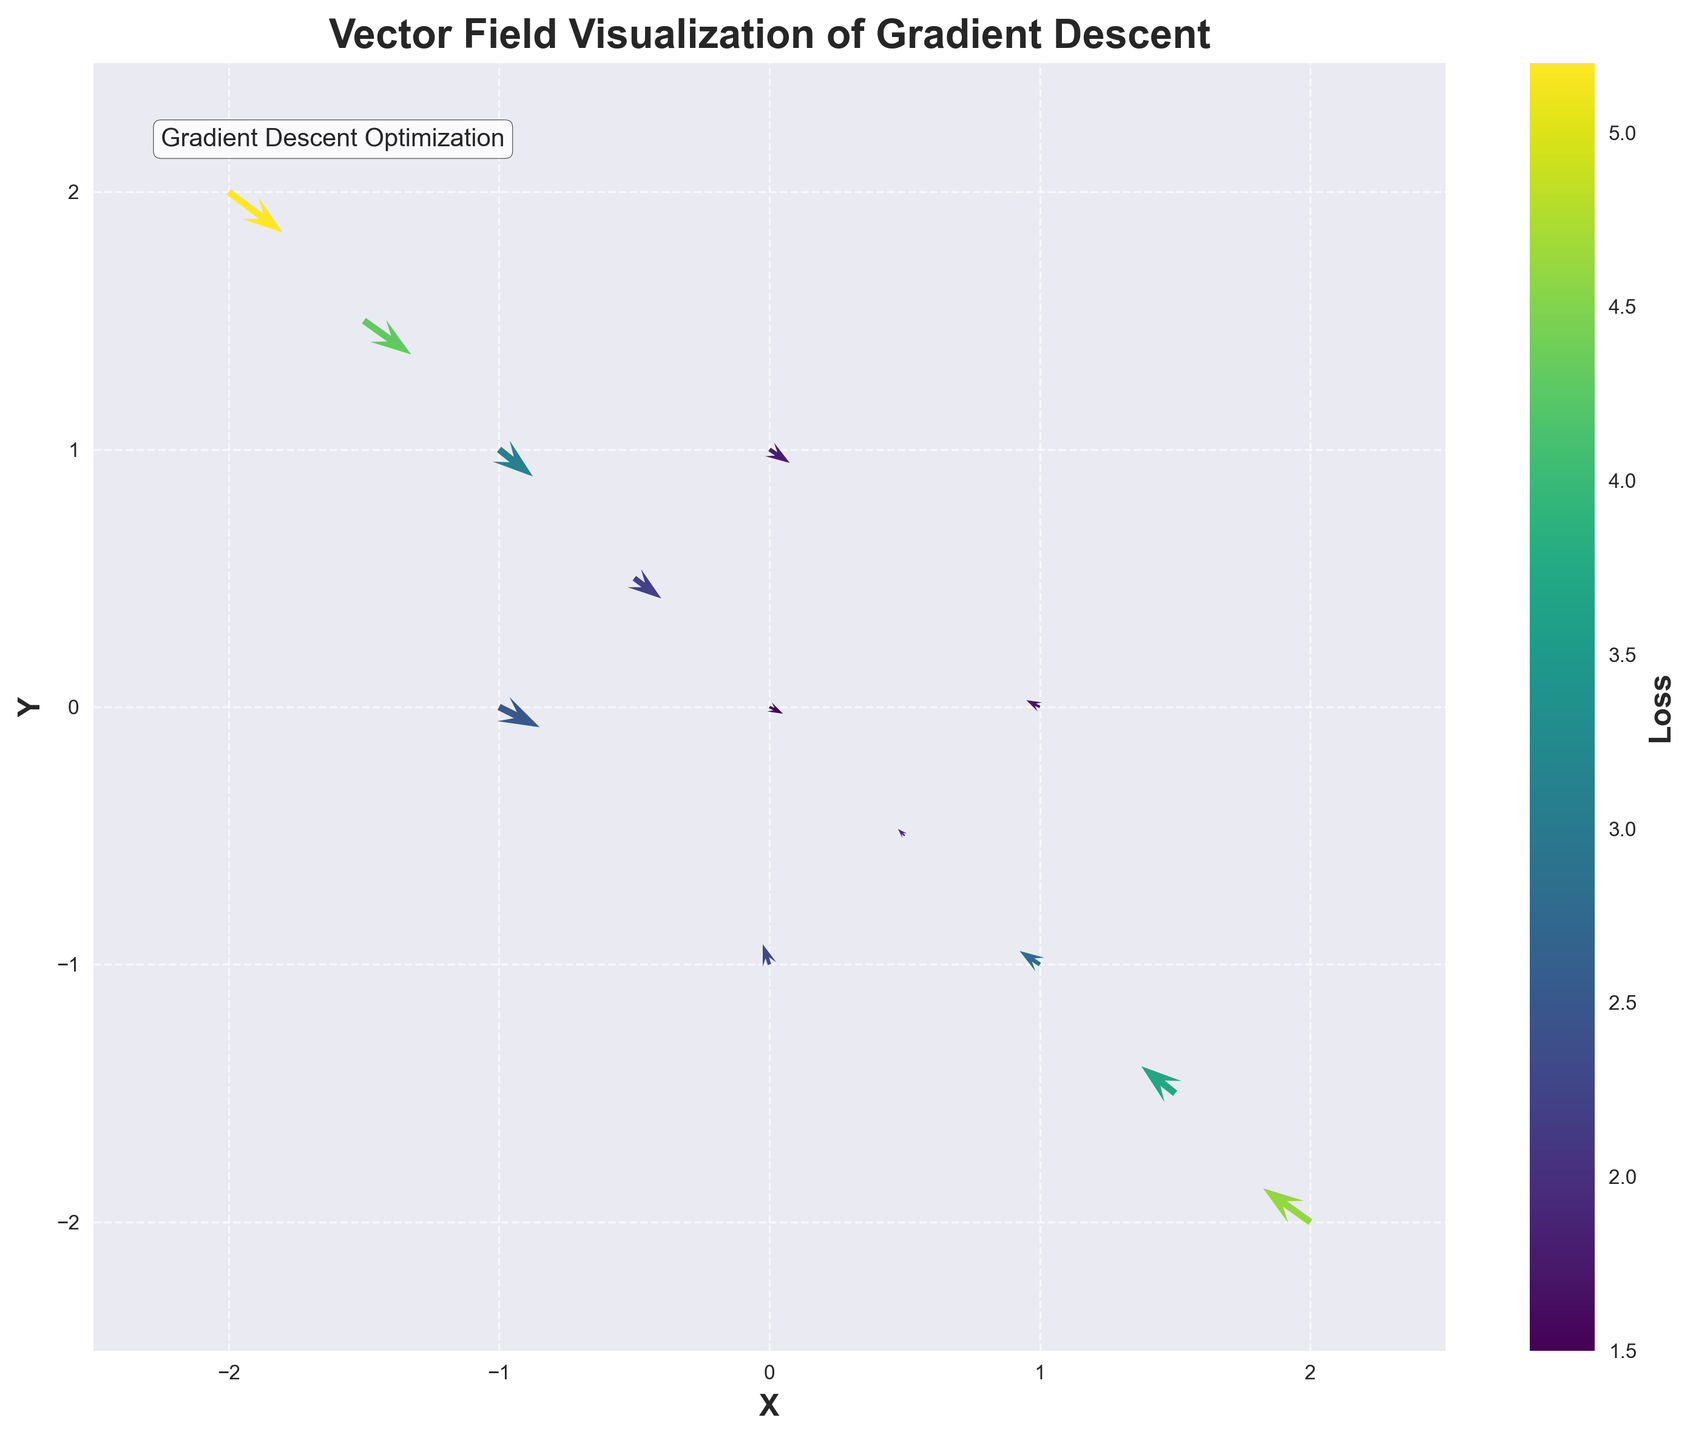What is the title of the quiver plot? The title of the plot is displayed at the top center of the figure
Answer: Vector Field Visualization of Gradient Descent How many data points are displayed in the plot? Count the number of arrows in the plot. Each represents a data point
Answer: 13 Which axis has a labeled range from -2.5 to 2.5? The x-axis and y-axis both have ranges from -2.5 to 2.5. Check the labels and limits on both axes
Answer: Both axes What color indicates the highest loss value? The colors represent loss values based on the colorbar. The highest loss corresponds to the lightest color on the 'viridis' color scale
Answer: Light yellow What does the length of an arrow in the quiver plot represent? The length of an arrow indicates the magnitude of the gradient (change in x and y directions) at that point
Answer: Magnitude of gradient Between the points (0, 0) and (1, -1), which has a lower loss value? Compare the loss values associated with both points. The color and corresponding number can be checked using the colorbar
Answer: (0, 0) Which point has the largest gradient magnitude? To find the largest gradient, calculate the magnitude √(dx² + dy²) for each data point and identify the highest value
Answer: (1, -1) What is the direction of the gradient at the point (-2, 2)? The direction of the gradient at (-2, 2) is indicated by the direction of the arrow originating from that point
Answer: Toward (0.8, -0.6) Are there any points where the gradient descent moves towards the negative x-axis? Check the arrows to see if they point left, indicating movement in the negative x-axis direction
Answer: Yes 